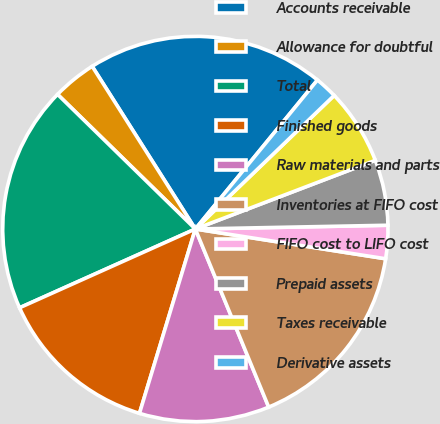<chart> <loc_0><loc_0><loc_500><loc_500><pie_chart><fcel>Accounts receivable<fcel>Allowance for doubtful<fcel>Total<fcel>Finished goods<fcel>Raw materials and parts<fcel>Inventories at FIFO cost<fcel>FIFO cost to LIFO cost<fcel>Prepaid assets<fcel>Taxes receivable<fcel>Derivative assets<nl><fcel>19.92%<fcel>3.69%<fcel>19.02%<fcel>13.61%<fcel>10.9%<fcel>16.31%<fcel>2.78%<fcel>5.49%<fcel>6.39%<fcel>1.88%<nl></chart> 